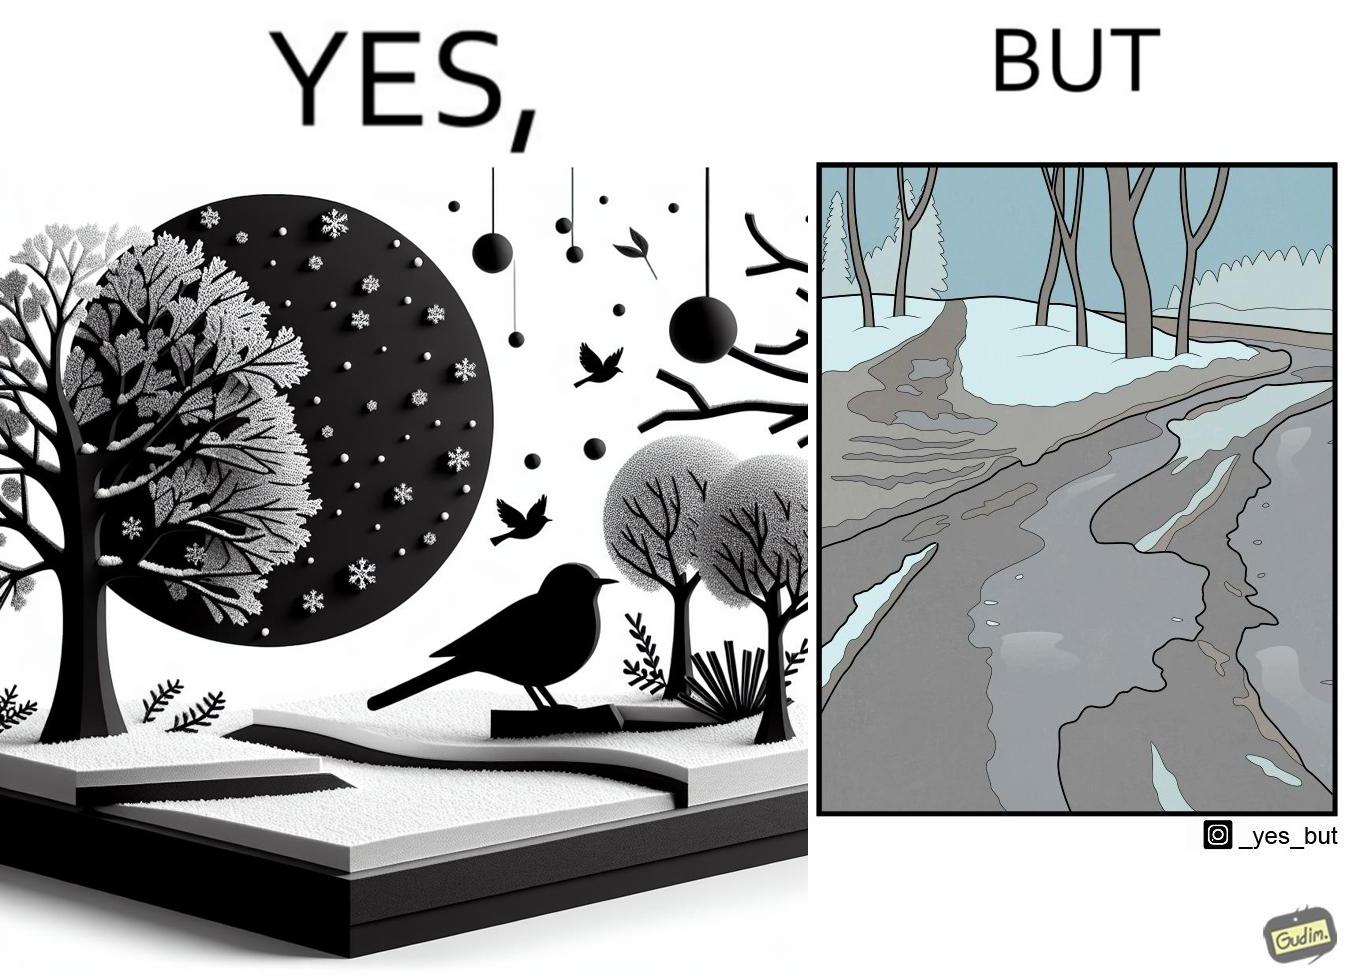What makes this image funny or satirical? The image is funny, as from far, snow covered mountains look really scenic and completely white, but when zooming in near trees, the ground is partially covered in snow, and is not as scenic anymore. 